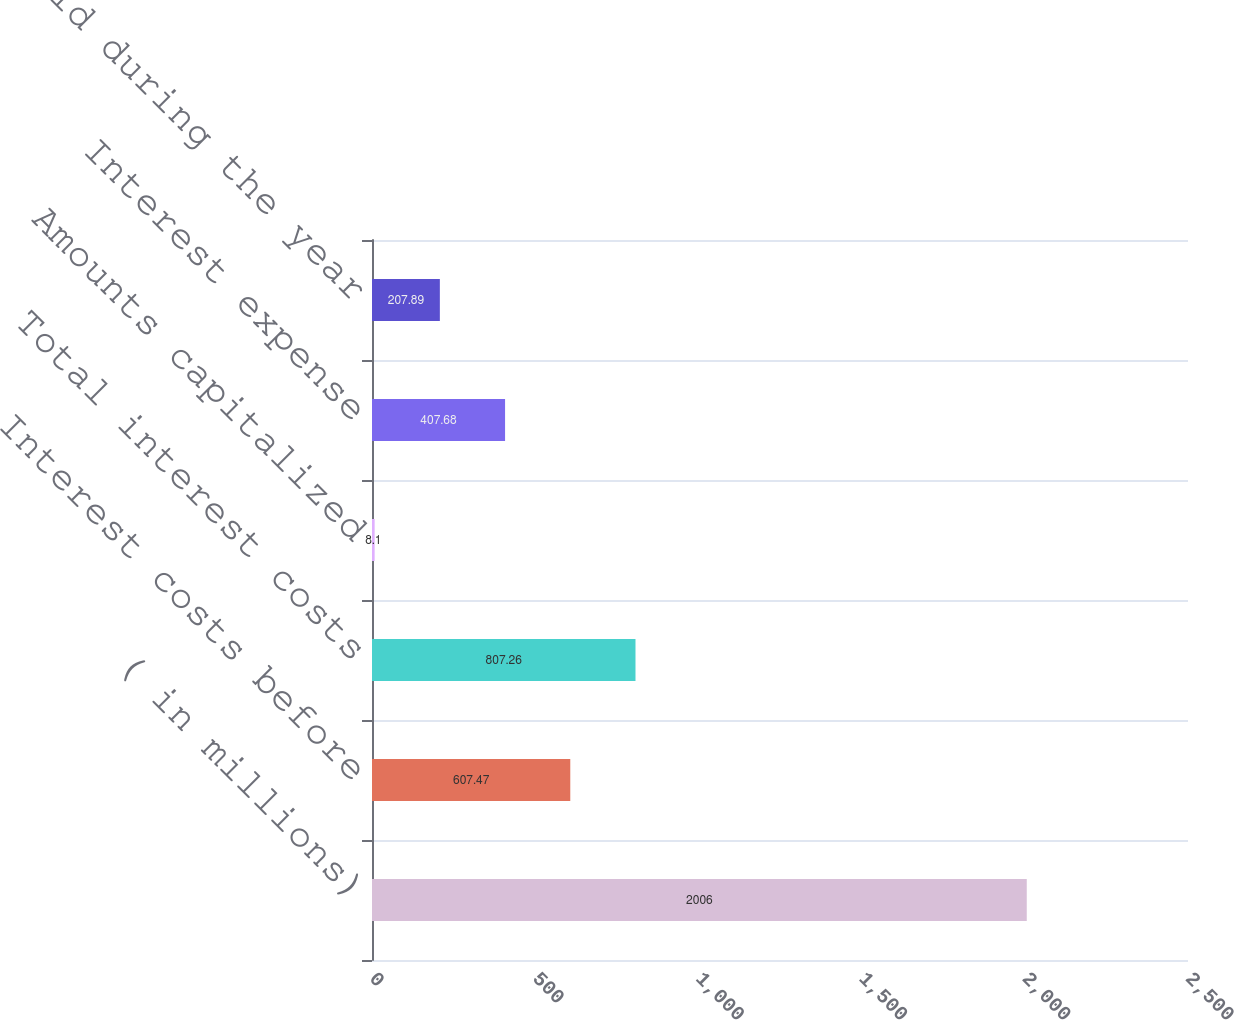Convert chart. <chart><loc_0><loc_0><loc_500><loc_500><bar_chart><fcel>( in millions)<fcel>Interest costs before<fcel>Total interest costs<fcel>Amounts capitalized<fcel>Interest expense<fcel>Interest paid during the year<nl><fcel>2006<fcel>607.47<fcel>807.26<fcel>8.1<fcel>407.68<fcel>207.89<nl></chart> 